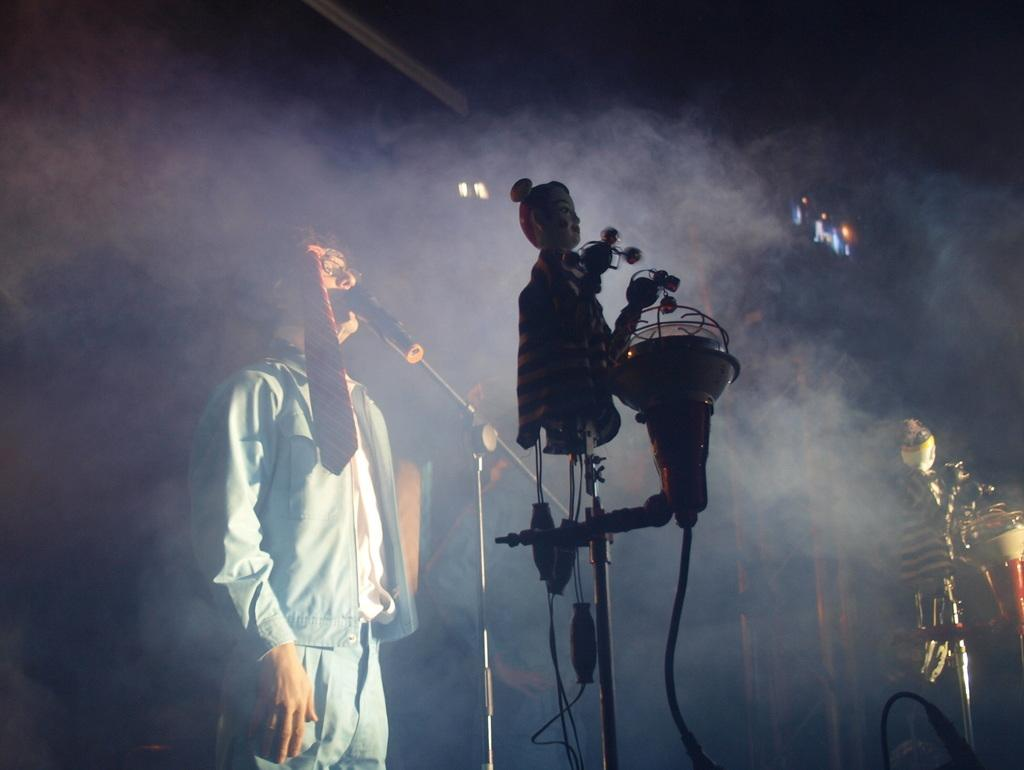Who is the main subject in the image? There is a man in the image. What is the man wearing? The man is wearing a sea green dress. What is the man doing in the image? The man is singing on a microphone. What can be seen behind the man? There are music instruments behind the man. What is the presence of smoke in the image indicating? The smoke may indicate a performance or a special effect being used during the performance. Can you tell me how many horses are present in the image? There are no horses present in the image; it features a man singing on a microphone with music instruments behind him. What is the man attempting to do with his arm in the image? The image does not show the man's arm or any specific actions with it, so it cannot be determined what he might be attempting to do. 